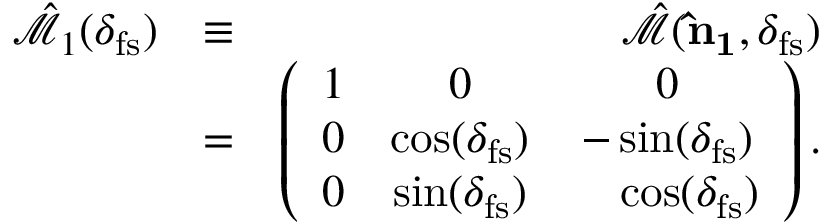<formula> <loc_0><loc_0><loc_500><loc_500>\begin{array} { r l r } { \hat { \mathcal { M } } _ { 1 } ( \delta _ { f s } ) } & { \equiv } & { \hat { \mathcal { M } } ( { \hat { n } _ { 1 } } , \delta _ { f s } ) } \\ & { = } & { \left ( \begin{array} { c c c } { 1 } & { 0 } & { 0 } \\ { 0 } & { \cos ( \delta _ { f s } ) } & { - \sin ( \delta _ { f s } ) } \\ { 0 } & { \sin ( \delta _ { f s } ) } & { \quad \cos ( \delta _ { f s } ) } \end{array} \right ) . } \end{array}</formula> 